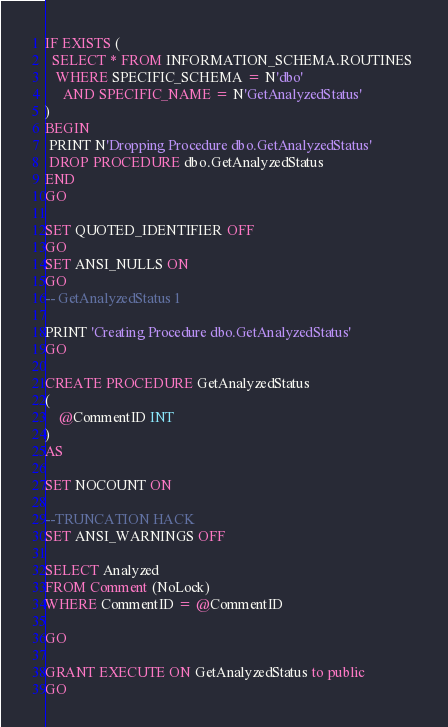<code> <loc_0><loc_0><loc_500><loc_500><_SQL_>IF EXISTS (
  SELECT * FROM INFORMATION_SCHEMA.ROUTINES 
   WHERE SPECIFIC_SCHEMA = N'dbo'
     AND SPECIFIC_NAME = N'GetAnalyzedStatus' 
)
BEGIN
 PRINT N'Dropping Procedure dbo.GetAnalyzedStatus'
 DROP PROCEDURE dbo.GetAnalyzedStatus
END
GO

SET QUOTED_IDENTIFIER OFF 
GO
SET ANSI_NULLS ON 
GO
-- GetAnalyzedStatus 1

PRINT 'Creating Procedure dbo.GetAnalyzedStatus'
GO

CREATE PROCEDURE GetAnalyzedStatus
(
	@CommentID INT
)
AS

SET NOCOUNT ON

--TRUNCATION HACK
SET ANSI_WARNINGS OFF

SELECT Analyzed
FROM Comment (NoLock)
WHERE CommentID = @CommentID

GO

GRANT EXECUTE ON GetAnalyzedStatus to public
GO</code> 